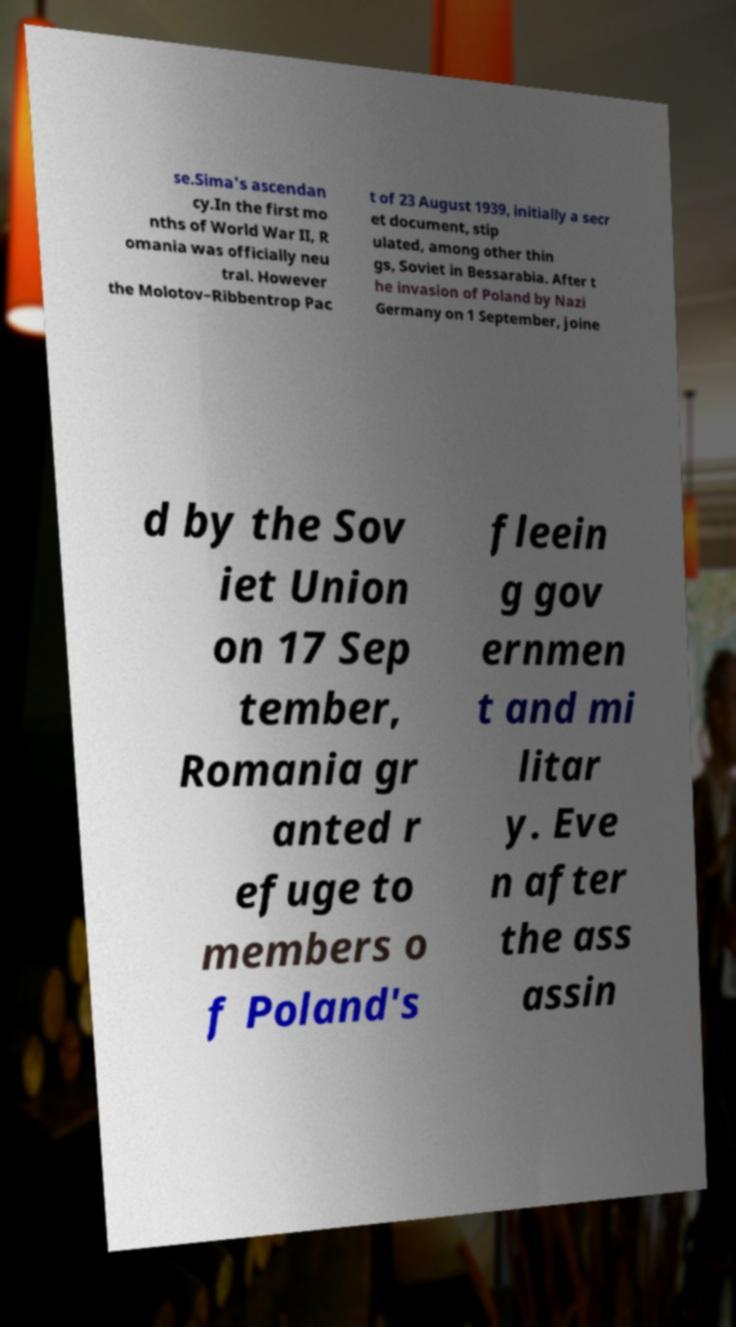What messages or text are displayed in this image? I need them in a readable, typed format. se.Sima's ascendan cy.In the first mo nths of World War II, R omania was officially neu tral. However the Molotov–Ribbentrop Pac t of 23 August 1939, initially a secr et document, stip ulated, among other thin gs, Soviet in Bessarabia. After t he invasion of Poland by Nazi Germany on 1 September, joine d by the Sov iet Union on 17 Sep tember, Romania gr anted r efuge to members o f Poland's fleein g gov ernmen t and mi litar y. Eve n after the ass assin 